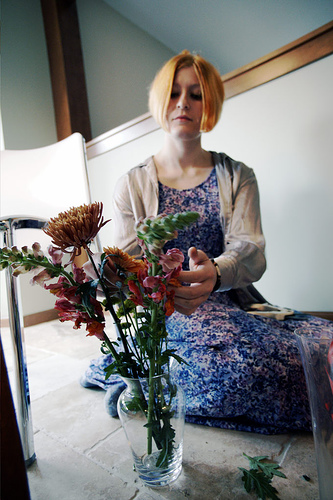<image>Is the woman wearing a watch? I am not sure if the woman is wearing a watch. What type of flowers are those? I don't know what type of flowers those are. They can be sunflower, mums, lilies, gladiolus, wildflowers, or carnations. Is the woman wearing a watch? I am not sure if the woman is wearing a watch. It can be both yes or no. What type of flowers are those? I don't know what type of flowers are those. It can be 'sunflower', 'mums', 'lilies', 'wild', 'gladiolus', 'wildflowers', or 'carnations'. 